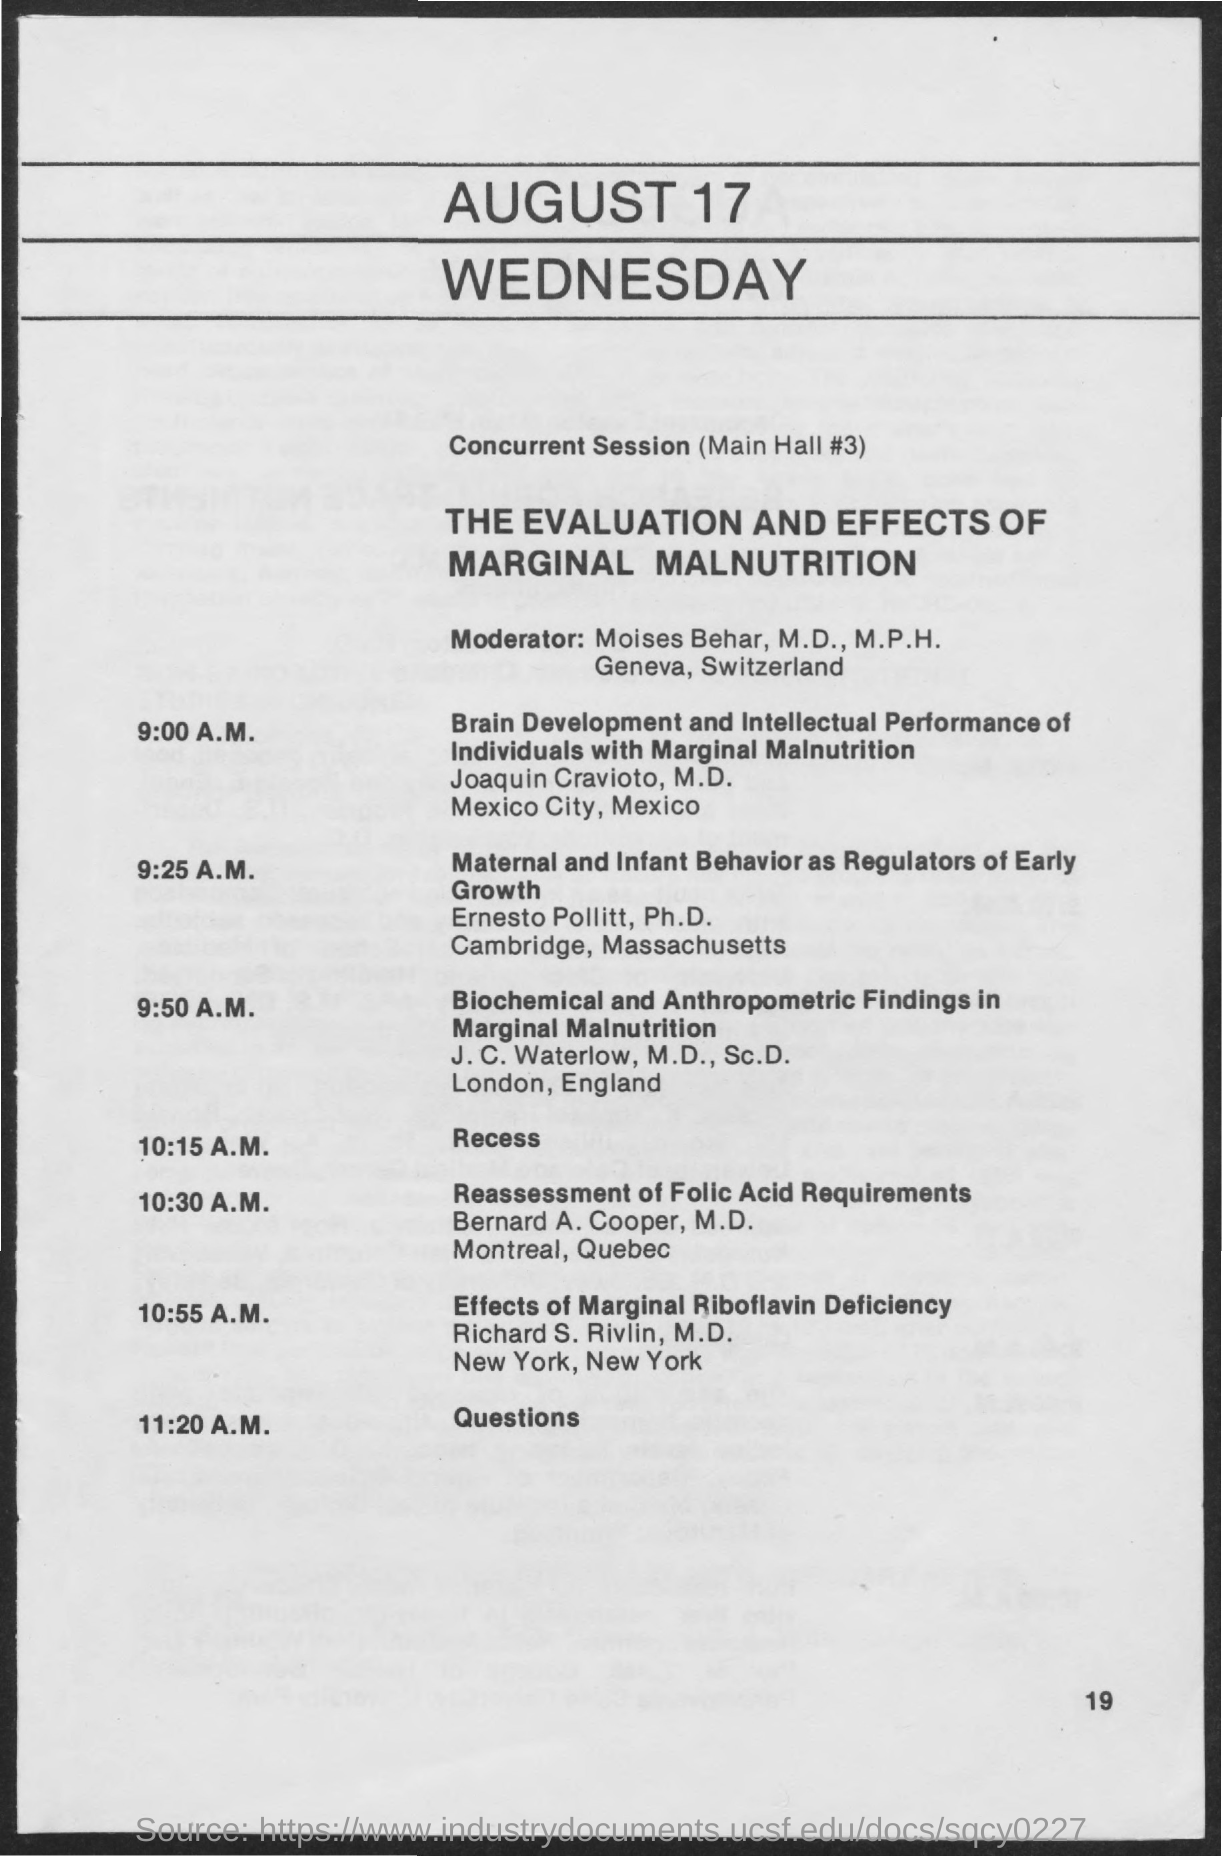What is the date on the document?
Provide a short and direct response. AUGUST 17. When is the Recess?
Provide a succinct answer. 10:15 A.M. 